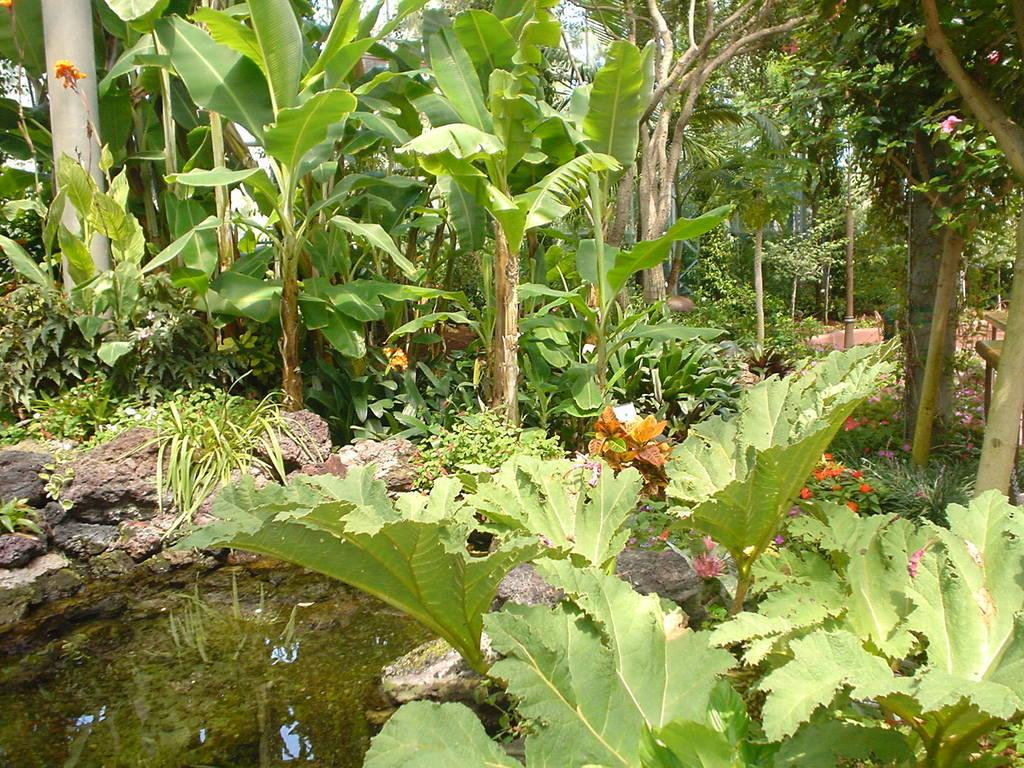What type of vegetation can be seen in the image? Plants, flowers, and trees can be seen in the image. Can you describe the water element in the image? Water is present in the left bottom of the image. What type of roof can be seen in the image? There is no roof present in the image. How does the silk appear in the image? There is no silk present in the image. 